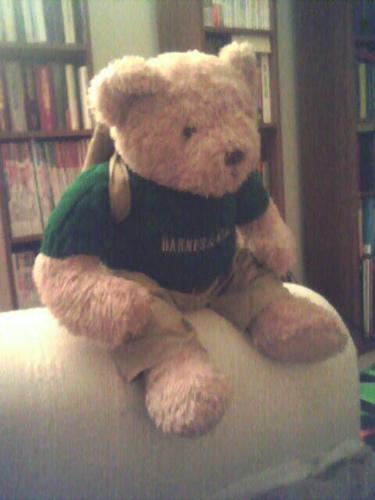Is the bear wearing a backpack?
Be succinct. Yes. What color is the teddy bears shirt?
Short answer required. Green. What color is the teddy bears nose?
Keep it brief. Black. 